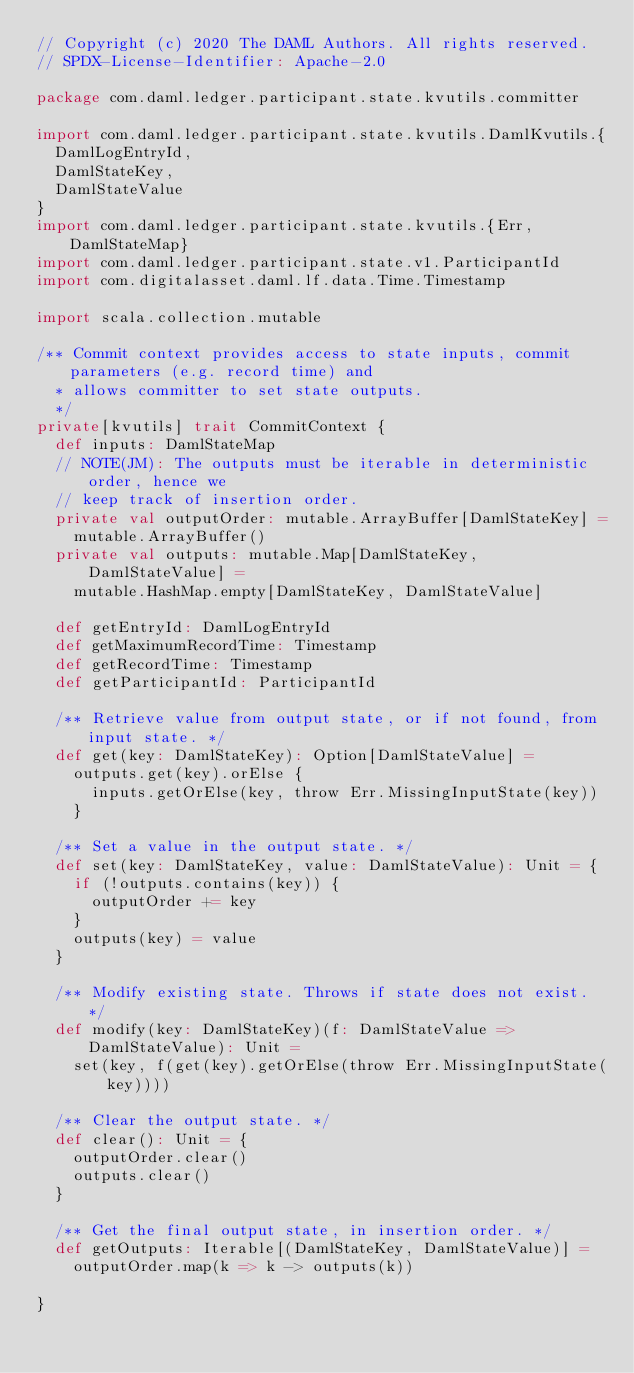Convert code to text. <code><loc_0><loc_0><loc_500><loc_500><_Scala_>// Copyright (c) 2020 The DAML Authors. All rights reserved.
// SPDX-License-Identifier: Apache-2.0

package com.daml.ledger.participant.state.kvutils.committer

import com.daml.ledger.participant.state.kvutils.DamlKvutils.{
  DamlLogEntryId,
  DamlStateKey,
  DamlStateValue
}
import com.daml.ledger.participant.state.kvutils.{Err, DamlStateMap}
import com.daml.ledger.participant.state.v1.ParticipantId
import com.digitalasset.daml.lf.data.Time.Timestamp

import scala.collection.mutable

/** Commit context provides access to state inputs, commit parameters (e.g. record time) and
  * allows committer to set state outputs.
  */
private[kvutils] trait CommitContext {
  def inputs: DamlStateMap
  // NOTE(JM): The outputs must be iterable in deterministic order, hence we
  // keep track of insertion order.
  private val outputOrder: mutable.ArrayBuffer[DamlStateKey] =
    mutable.ArrayBuffer()
  private val outputs: mutable.Map[DamlStateKey, DamlStateValue] =
    mutable.HashMap.empty[DamlStateKey, DamlStateValue]

  def getEntryId: DamlLogEntryId
  def getMaximumRecordTime: Timestamp
  def getRecordTime: Timestamp
  def getParticipantId: ParticipantId

  /** Retrieve value from output state, or if not found, from input state. */
  def get(key: DamlStateKey): Option[DamlStateValue] =
    outputs.get(key).orElse {
      inputs.getOrElse(key, throw Err.MissingInputState(key))
    }

  /** Set a value in the output state. */
  def set(key: DamlStateKey, value: DamlStateValue): Unit = {
    if (!outputs.contains(key)) {
      outputOrder += key
    }
    outputs(key) = value
  }

  /** Modify existing state. Throws if state does not exist. */
  def modify(key: DamlStateKey)(f: DamlStateValue => DamlStateValue): Unit =
    set(key, f(get(key).getOrElse(throw Err.MissingInputState(key))))

  /** Clear the output state. */
  def clear(): Unit = {
    outputOrder.clear()
    outputs.clear()
  }

  /** Get the final output state, in insertion order. */
  def getOutputs: Iterable[(DamlStateKey, DamlStateValue)] =
    outputOrder.map(k => k -> outputs(k))

}
</code> 